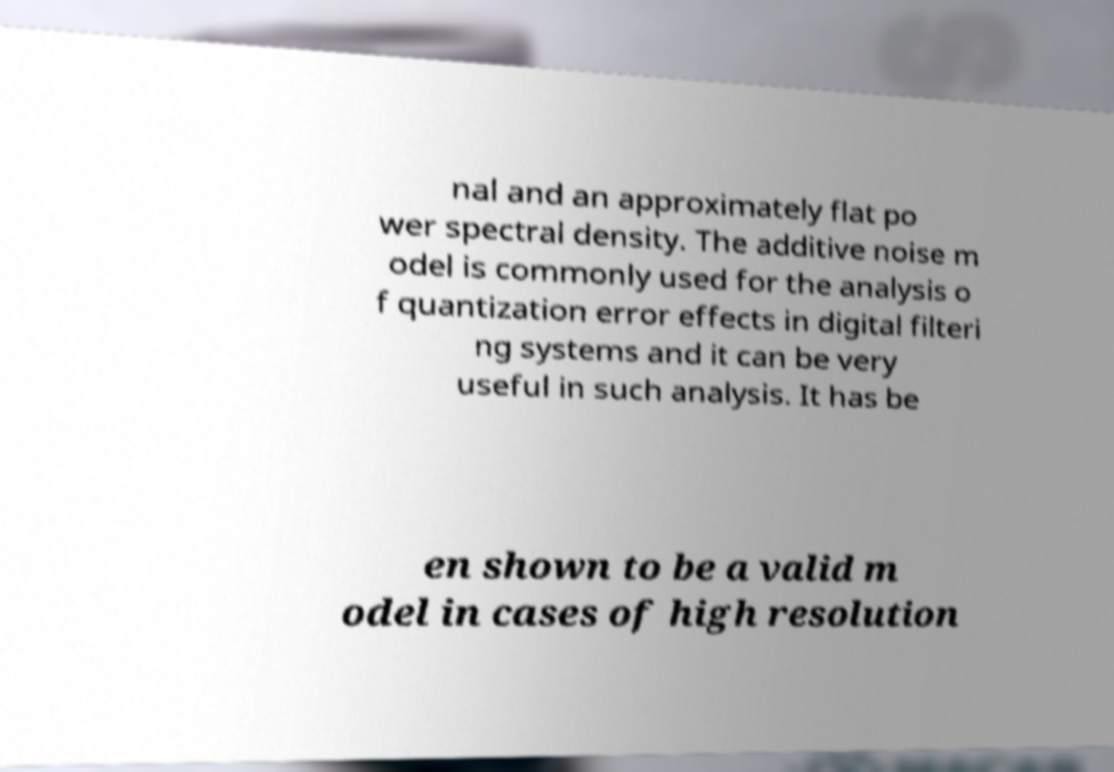There's text embedded in this image that I need extracted. Can you transcribe it verbatim? nal and an approximately flat po wer spectral density. The additive noise m odel is commonly used for the analysis o f quantization error effects in digital filteri ng systems and it can be very useful in such analysis. It has be en shown to be a valid m odel in cases of high resolution 